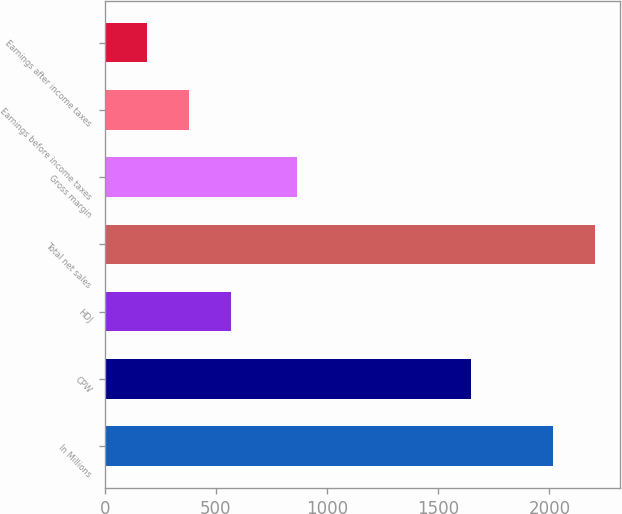<chart> <loc_0><loc_0><loc_500><loc_500><bar_chart><fcel>In Millions<fcel>CPW<fcel>HDJ<fcel>Total net sales<fcel>Gross margin<fcel>Earnings before income taxes<fcel>Earnings after income taxes<nl><fcel>2017<fcel>1648.4<fcel>568.94<fcel>2206.32<fcel>865.9<fcel>379.62<fcel>190.3<nl></chart> 